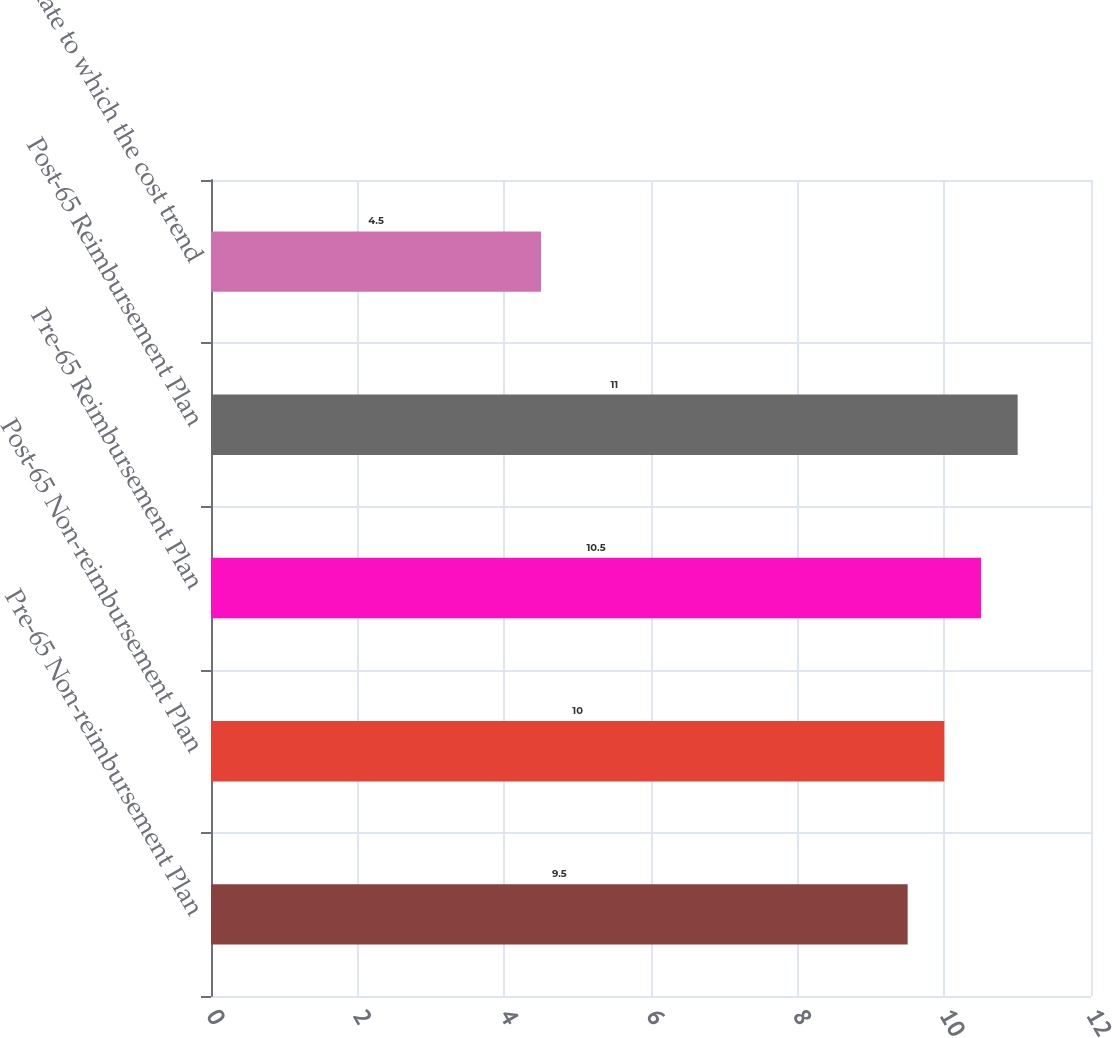Convert chart. <chart><loc_0><loc_0><loc_500><loc_500><bar_chart><fcel>Pre-65 Non-reimbursement Plan<fcel>Post-65 Non-reimbursement Plan<fcel>Pre-65 Reimbursement Plan<fcel>Post-65 Reimbursement Plan<fcel>Rate to which the cost trend<nl><fcel>9.5<fcel>10<fcel>10.5<fcel>11<fcel>4.5<nl></chart> 